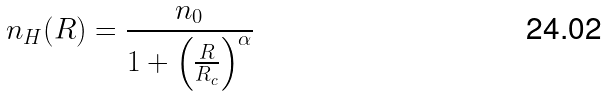Convert formula to latex. <formula><loc_0><loc_0><loc_500><loc_500>n _ { H } ( R ) = \frac { n _ { 0 } } { 1 + \left ( \frac { R } { R _ { c } } \right ) ^ { \alpha } }</formula> 